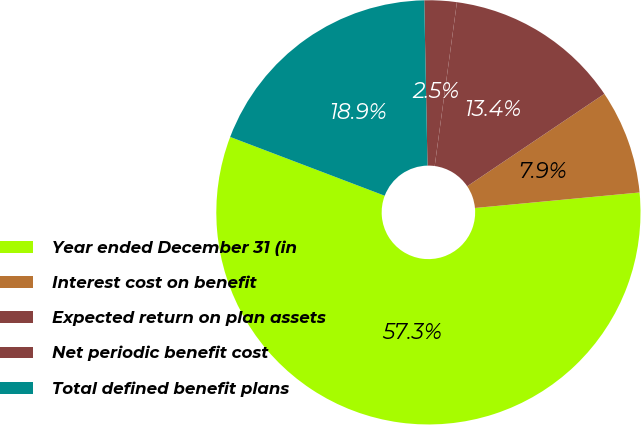Convert chart. <chart><loc_0><loc_0><loc_500><loc_500><pie_chart><fcel>Year ended December 31 (in<fcel>Interest cost on benefit<fcel>Expected return on plan assets<fcel>Net periodic benefit cost<fcel>Total defined benefit plans<nl><fcel>57.28%<fcel>7.94%<fcel>13.42%<fcel>2.46%<fcel>18.9%<nl></chart> 